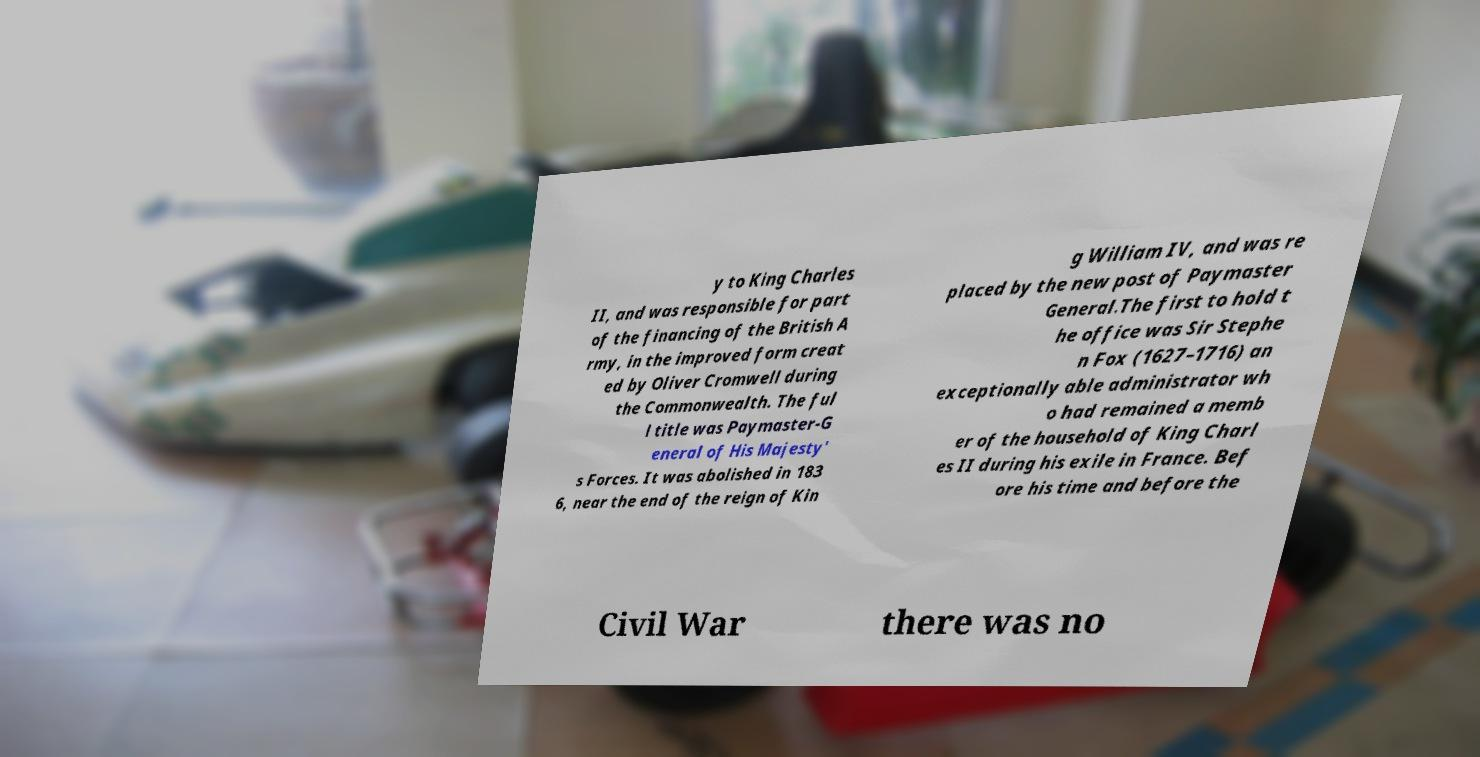For documentation purposes, I need the text within this image transcribed. Could you provide that? y to King Charles II, and was responsible for part of the financing of the British A rmy, in the improved form creat ed by Oliver Cromwell during the Commonwealth. The ful l title was Paymaster-G eneral of His Majesty' s Forces. It was abolished in 183 6, near the end of the reign of Kin g William IV, and was re placed by the new post of Paymaster General.The first to hold t he office was Sir Stephe n Fox (1627–1716) an exceptionally able administrator wh o had remained a memb er of the household of King Charl es II during his exile in France. Bef ore his time and before the Civil War there was no 